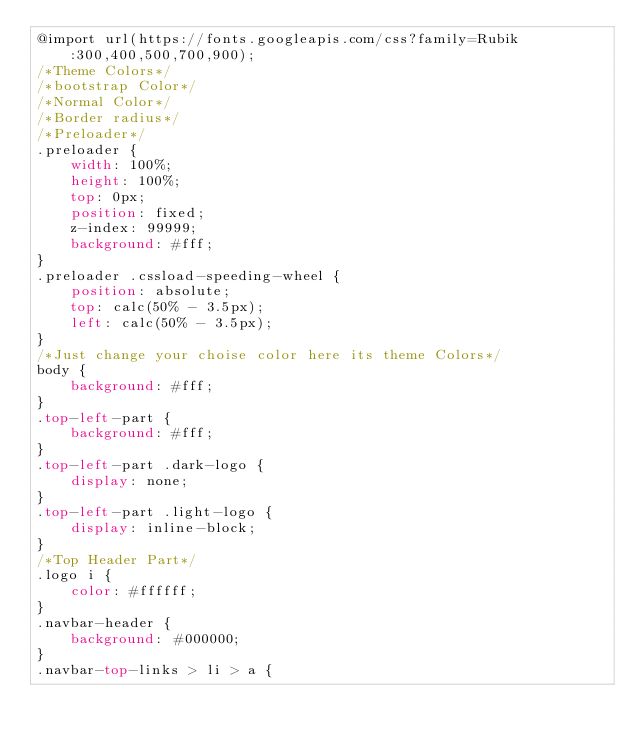Convert code to text. <code><loc_0><loc_0><loc_500><loc_500><_CSS_>@import url(https://fonts.googleapis.com/css?family=Rubik:300,400,500,700,900);
/*Theme Colors*/
/*bootstrap Color*/
/*Normal Color*/
/*Border radius*/
/*Preloader*/
.preloader {
    width: 100%;
    height: 100%;
    top: 0px;
    position: fixed;
    z-index: 99999;
    background: #fff;
}
.preloader .cssload-speeding-wheel {
    position: absolute;
    top: calc(50% - 3.5px);
    left: calc(50% - 3.5px);
}
/*Just change your choise color here its theme Colors*/
body {
    background: #fff;
}
.top-left-part {
    background: #fff;
}
.top-left-part .dark-logo {
    display: none;
}
.top-left-part .light-logo {
    display: inline-block;
}
/*Top Header Part*/
.logo i {
    color: #ffffff;
}
.navbar-header {
    background: #000000;
}
.navbar-top-links > li > a {</code> 